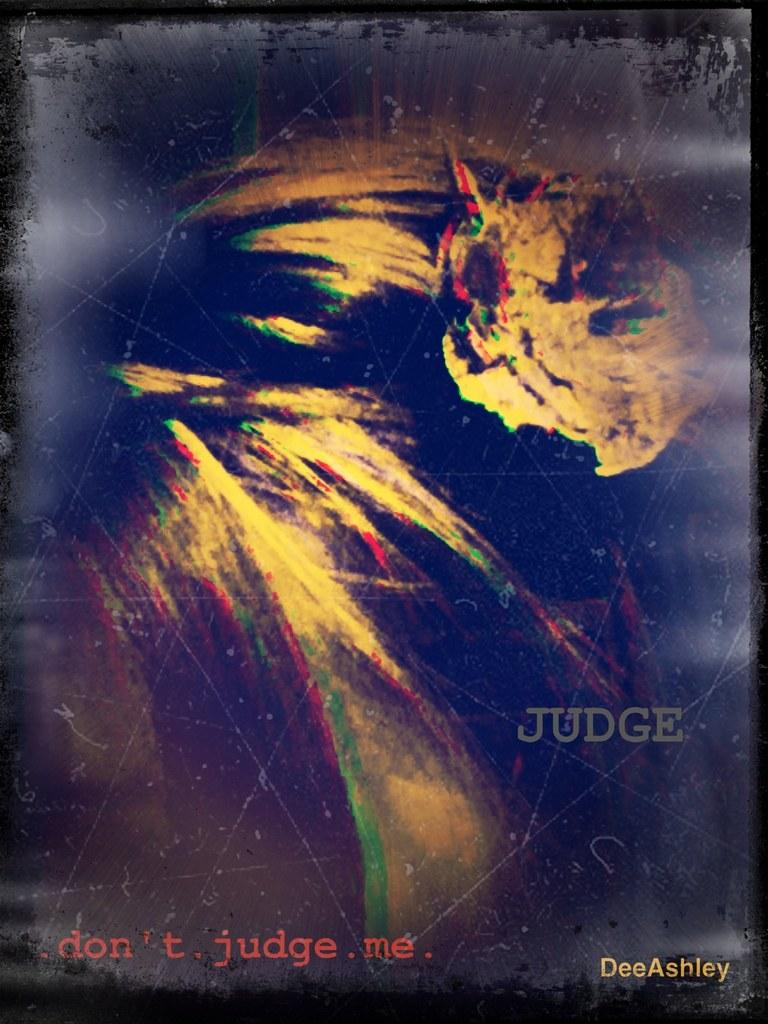<image>
Render a clear and concise summary of the photo. Drawing which has the word "JUDGE" in gray. 